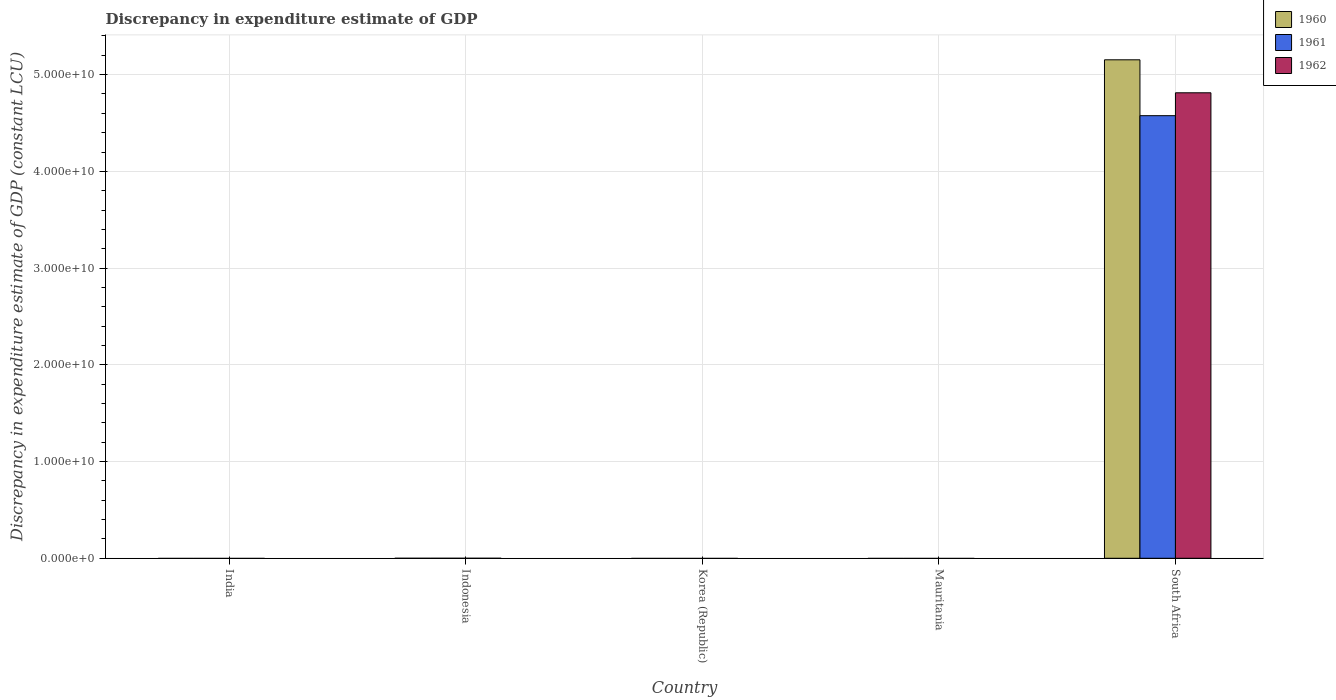Are the number of bars per tick equal to the number of legend labels?
Your response must be concise. No. Are the number of bars on each tick of the X-axis equal?
Provide a short and direct response. No. What is the label of the 5th group of bars from the left?
Give a very brief answer. South Africa. In how many cases, is the number of bars for a given country not equal to the number of legend labels?
Ensure brevity in your answer.  4. What is the discrepancy in expenditure estimate of GDP in 1962 in South Africa?
Provide a succinct answer. 4.81e+1. Across all countries, what is the maximum discrepancy in expenditure estimate of GDP in 1961?
Your answer should be compact. 4.58e+1. In which country was the discrepancy in expenditure estimate of GDP in 1961 maximum?
Offer a terse response. South Africa. What is the total discrepancy in expenditure estimate of GDP in 1960 in the graph?
Your response must be concise. 5.15e+1. What is the average discrepancy in expenditure estimate of GDP in 1960 per country?
Make the answer very short. 1.03e+1. What is the difference between the discrepancy in expenditure estimate of GDP of/in 1961 and discrepancy in expenditure estimate of GDP of/in 1962 in South Africa?
Offer a terse response. -2.37e+09. What is the difference between the highest and the lowest discrepancy in expenditure estimate of GDP in 1961?
Provide a short and direct response. 4.58e+1. In how many countries, is the discrepancy in expenditure estimate of GDP in 1961 greater than the average discrepancy in expenditure estimate of GDP in 1961 taken over all countries?
Your answer should be compact. 1. Are all the bars in the graph horizontal?
Your answer should be compact. No. How many countries are there in the graph?
Make the answer very short. 5. What is the difference between two consecutive major ticks on the Y-axis?
Provide a short and direct response. 1.00e+1. Does the graph contain any zero values?
Provide a succinct answer. Yes. How many legend labels are there?
Your answer should be very brief. 3. What is the title of the graph?
Your answer should be very brief. Discrepancy in expenditure estimate of GDP. Does "1967" appear as one of the legend labels in the graph?
Offer a very short reply. No. What is the label or title of the Y-axis?
Provide a short and direct response. Discrepancy in expenditure estimate of GDP (constant LCU). What is the Discrepancy in expenditure estimate of GDP (constant LCU) in 1961 in India?
Provide a short and direct response. 0. What is the Discrepancy in expenditure estimate of GDP (constant LCU) in 1962 in India?
Offer a terse response. 0. What is the Discrepancy in expenditure estimate of GDP (constant LCU) in 1960 in Indonesia?
Provide a succinct answer. 0. What is the Discrepancy in expenditure estimate of GDP (constant LCU) of 1960 in Korea (Republic)?
Make the answer very short. 0. What is the Discrepancy in expenditure estimate of GDP (constant LCU) in 1962 in Korea (Republic)?
Provide a short and direct response. 0. What is the Discrepancy in expenditure estimate of GDP (constant LCU) in 1960 in Mauritania?
Give a very brief answer. 0. What is the Discrepancy in expenditure estimate of GDP (constant LCU) in 1962 in Mauritania?
Your answer should be compact. 0. What is the Discrepancy in expenditure estimate of GDP (constant LCU) in 1960 in South Africa?
Offer a very short reply. 5.15e+1. What is the Discrepancy in expenditure estimate of GDP (constant LCU) in 1961 in South Africa?
Provide a short and direct response. 4.58e+1. What is the Discrepancy in expenditure estimate of GDP (constant LCU) of 1962 in South Africa?
Provide a succinct answer. 4.81e+1. Across all countries, what is the maximum Discrepancy in expenditure estimate of GDP (constant LCU) in 1960?
Provide a succinct answer. 5.15e+1. Across all countries, what is the maximum Discrepancy in expenditure estimate of GDP (constant LCU) of 1961?
Offer a very short reply. 4.58e+1. Across all countries, what is the maximum Discrepancy in expenditure estimate of GDP (constant LCU) in 1962?
Make the answer very short. 4.81e+1. Across all countries, what is the minimum Discrepancy in expenditure estimate of GDP (constant LCU) of 1962?
Ensure brevity in your answer.  0. What is the total Discrepancy in expenditure estimate of GDP (constant LCU) in 1960 in the graph?
Your answer should be very brief. 5.15e+1. What is the total Discrepancy in expenditure estimate of GDP (constant LCU) in 1961 in the graph?
Keep it short and to the point. 4.58e+1. What is the total Discrepancy in expenditure estimate of GDP (constant LCU) in 1962 in the graph?
Give a very brief answer. 4.81e+1. What is the average Discrepancy in expenditure estimate of GDP (constant LCU) in 1960 per country?
Ensure brevity in your answer.  1.03e+1. What is the average Discrepancy in expenditure estimate of GDP (constant LCU) of 1961 per country?
Give a very brief answer. 9.15e+09. What is the average Discrepancy in expenditure estimate of GDP (constant LCU) in 1962 per country?
Give a very brief answer. 9.62e+09. What is the difference between the Discrepancy in expenditure estimate of GDP (constant LCU) of 1960 and Discrepancy in expenditure estimate of GDP (constant LCU) of 1961 in South Africa?
Your answer should be very brief. 5.78e+09. What is the difference between the Discrepancy in expenditure estimate of GDP (constant LCU) of 1960 and Discrepancy in expenditure estimate of GDP (constant LCU) of 1962 in South Africa?
Ensure brevity in your answer.  3.41e+09. What is the difference between the Discrepancy in expenditure estimate of GDP (constant LCU) in 1961 and Discrepancy in expenditure estimate of GDP (constant LCU) in 1962 in South Africa?
Provide a succinct answer. -2.37e+09. What is the difference between the highest and the lowest Discrepancy in expenditure estimate of GDP (constant LCU) of 1960?
Give a very brief answer. 5.15e+1. What is the difference between the highest and the lowest Discrepancy in expenditure estimate of GDP (constant LCU) in 1961?
Make the answer very short. 4.58e+1. What is the difference between the highest and the lowest Discrepancy in expenditure estimate of GDP (constant LCU) in 1962?
Your response must be concise. 4.81e+1. 